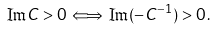Convert formula to latex. <formula><loc_0><loc_0><loc_500><loc_500>\Im C > 0 \, \Longleftrightarrow \, \Im ( - C ^ { - 1 } ) > 0 \, .</formula> 